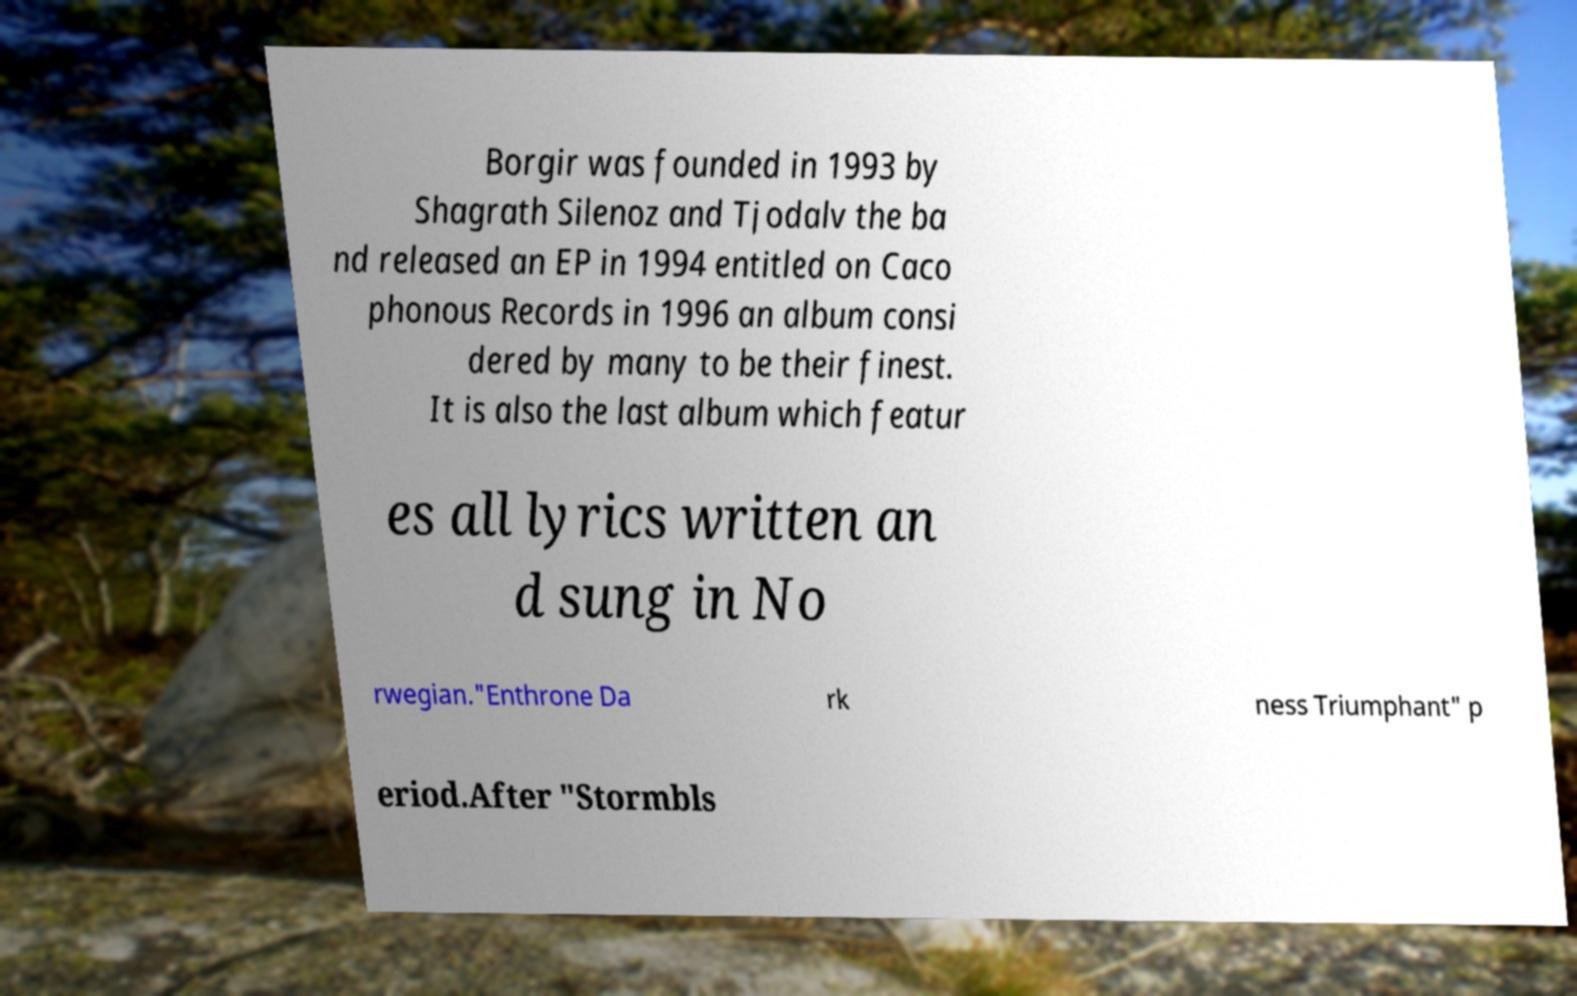For documentation purposes, I need the text within this image transcribed. Could you provide that? Borgir was founded in 1993 by Shagrath Silenoz and Tjodalv the ba nd released an EP in 1994 entitled on Caco phonous Records in 1996 an album consi dered by many to be their finest. It is also the last album which featur es all lyrics written an d sung in No rwegian."Enthrone Da rk ness Triumphant" p eriod.After "Stormbls 